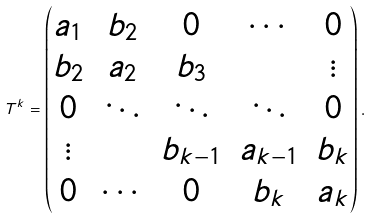Convert formula to latex. <formula><loc_0><loc_0><loc_500><loc_500>T ^ { k } = \left ( \begin{matrix} a _ { 1 } & b _ { 2 } & 0 & \cdots & 0 \\ b _ { 2 } & a _ { 2 } & b _ { 3 } & & \vdots \\ 0 & \ddots & \ddots & \ddots & 0 \\ \vdots & & b _ { k - 1 } & a _ { k - 1 } & b _ { k } \\ 0 & \cdots & 0 & b _ { k } & a _ { k } \\ \end{matrix} \right ) .</formula> 